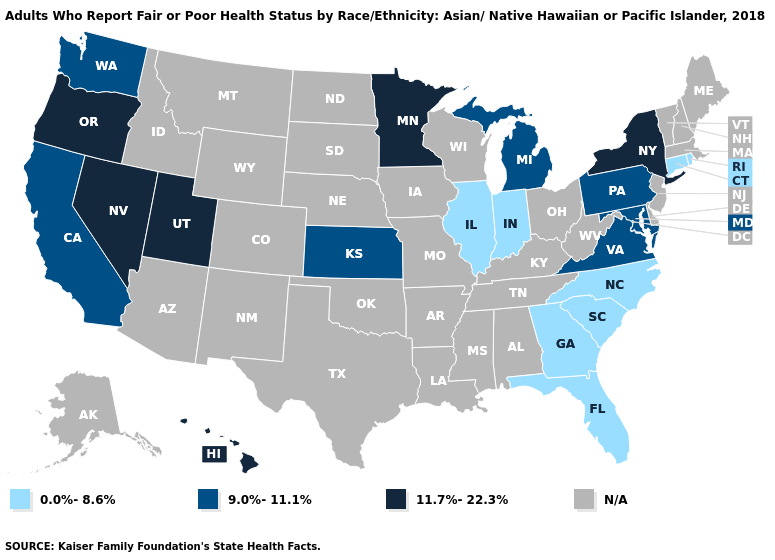Name the states that have a value in the range 0.0%-8.6%?
Be succinct. Connecticut, Florida, Georgia, Illinois, Indiana, North Carolina, Rhode Island, South Carolina. Does Minnesota have the highest value in the USA?
Concise answer only. Yes. What is the value of Wyoming?
Write a very short answer. N/A. Name the states that have a value in the range N/A?
Concise answer only. Alabama, Alaska, Arizona, Arkansas, Colorado, Delaware, Idaho, Iowa, Kentucky, Louisiana, Maine, Massachusetts, Mississippi, Missouri, Montana, Nebraska, New Hampshire, New Jersey, New Mexico, North Dakota, Ohio, Oklahoma, South Dakota, Tennessee, Texas, Vermont, West Virginia, Wisconsin, Wyoming. Which states have the highest value in the USA?
Quick response, please. Hawaii, Minnesota, Nevada, New York, Oregon, Utah. What is the value of South Carolina?
Concise answer only. 0.0%-8.6%. What is the value of North Dakota?
Short answer required. N/A. Name the states that have a value in the range 11.7%-22.3%?
Write a very short answer. Hawaii, Minnesota, Nevada, New York, Oregon, Utah. Name the states that have a value in the range 11.7%-22.3%?
Answer briefly. Hawaii, Minnesota, Nevada, New York, Oregon, Utah. What is the value of South Carolina?
Answer briefly. 0.0%-8.6%. Which states have the lowest value in the USA?
Give a very brief answer. Connecticut, Florida, Georgia, Illinois, Indiana, North Carolina, Rhode Island, South Carolina. Which states have the lowest value in the USA?
Answer briefly. Connecticut, Florida, Georgia, Illinois, Indiana, North Carolina, Rhode Island, South Carolina. 